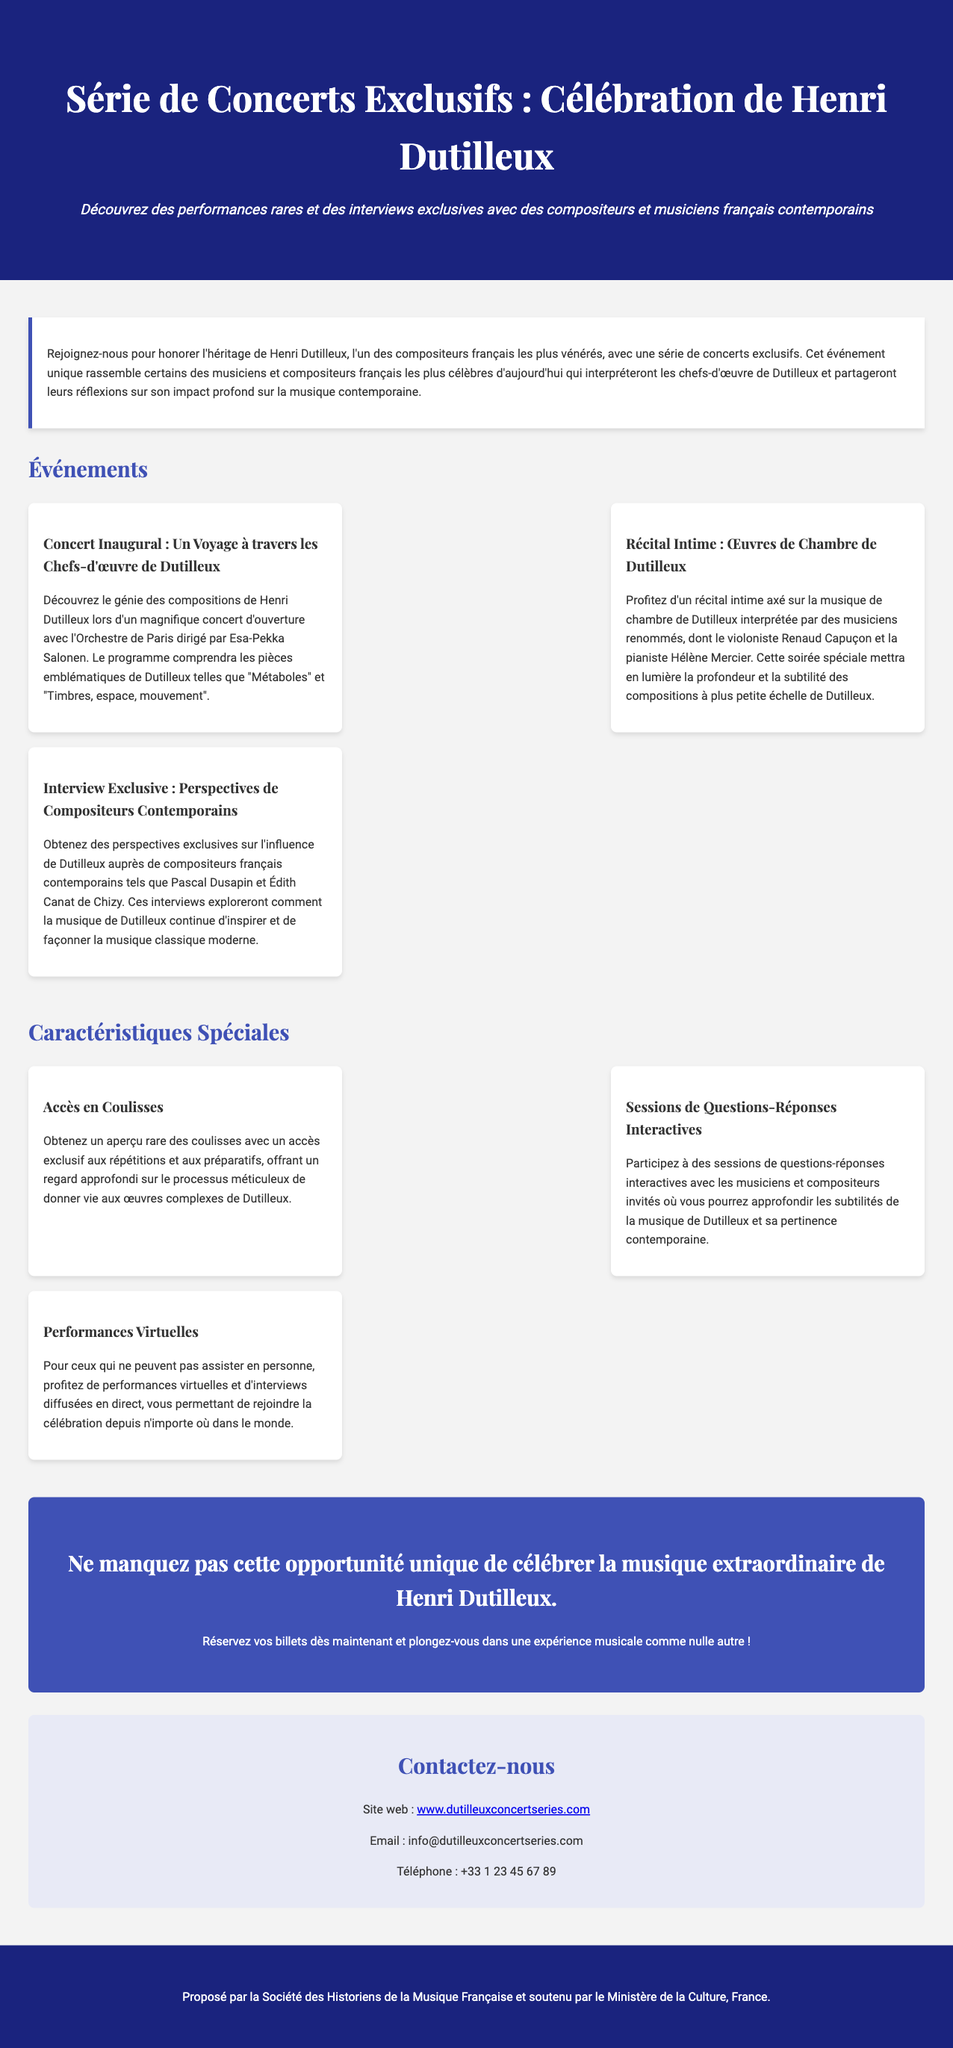Quel est le titre de la série de concerts ? Le titre de la série de concerts est "Série de Concerts Exclusifs : Célébration de Henri Dutilleux".
Answer: Série de Concerts Exclusifs : Célébration de Henri Dutilleux Qui dirige le concert inaugural ? Le concert inaugural est dirigé par Esa-Pekka Salonen.
Answer: Esa-Pekka Salonen Quels sont deux compositeurs contemporains mentionnés dans l'interview exclusive ? Les compositeurs contemporains mentionnés sont Pascal Dusapin et Édith Canat de Chizy.
Answer: Pascal Dusapin et Édith Canat de Chizy Quel type de performances sont proposées pour ceux qui ne peuvent pas assister en personne ? Les performances proposées pour ceux qui ne peuvent pas assister en personne sont des performances virtuelles.
Answer: Performances virtuelles Combien de concerts sont mentionnés dans les événements ? Trois concerts sont mentionnés dans les événements.
Answer: Trois 